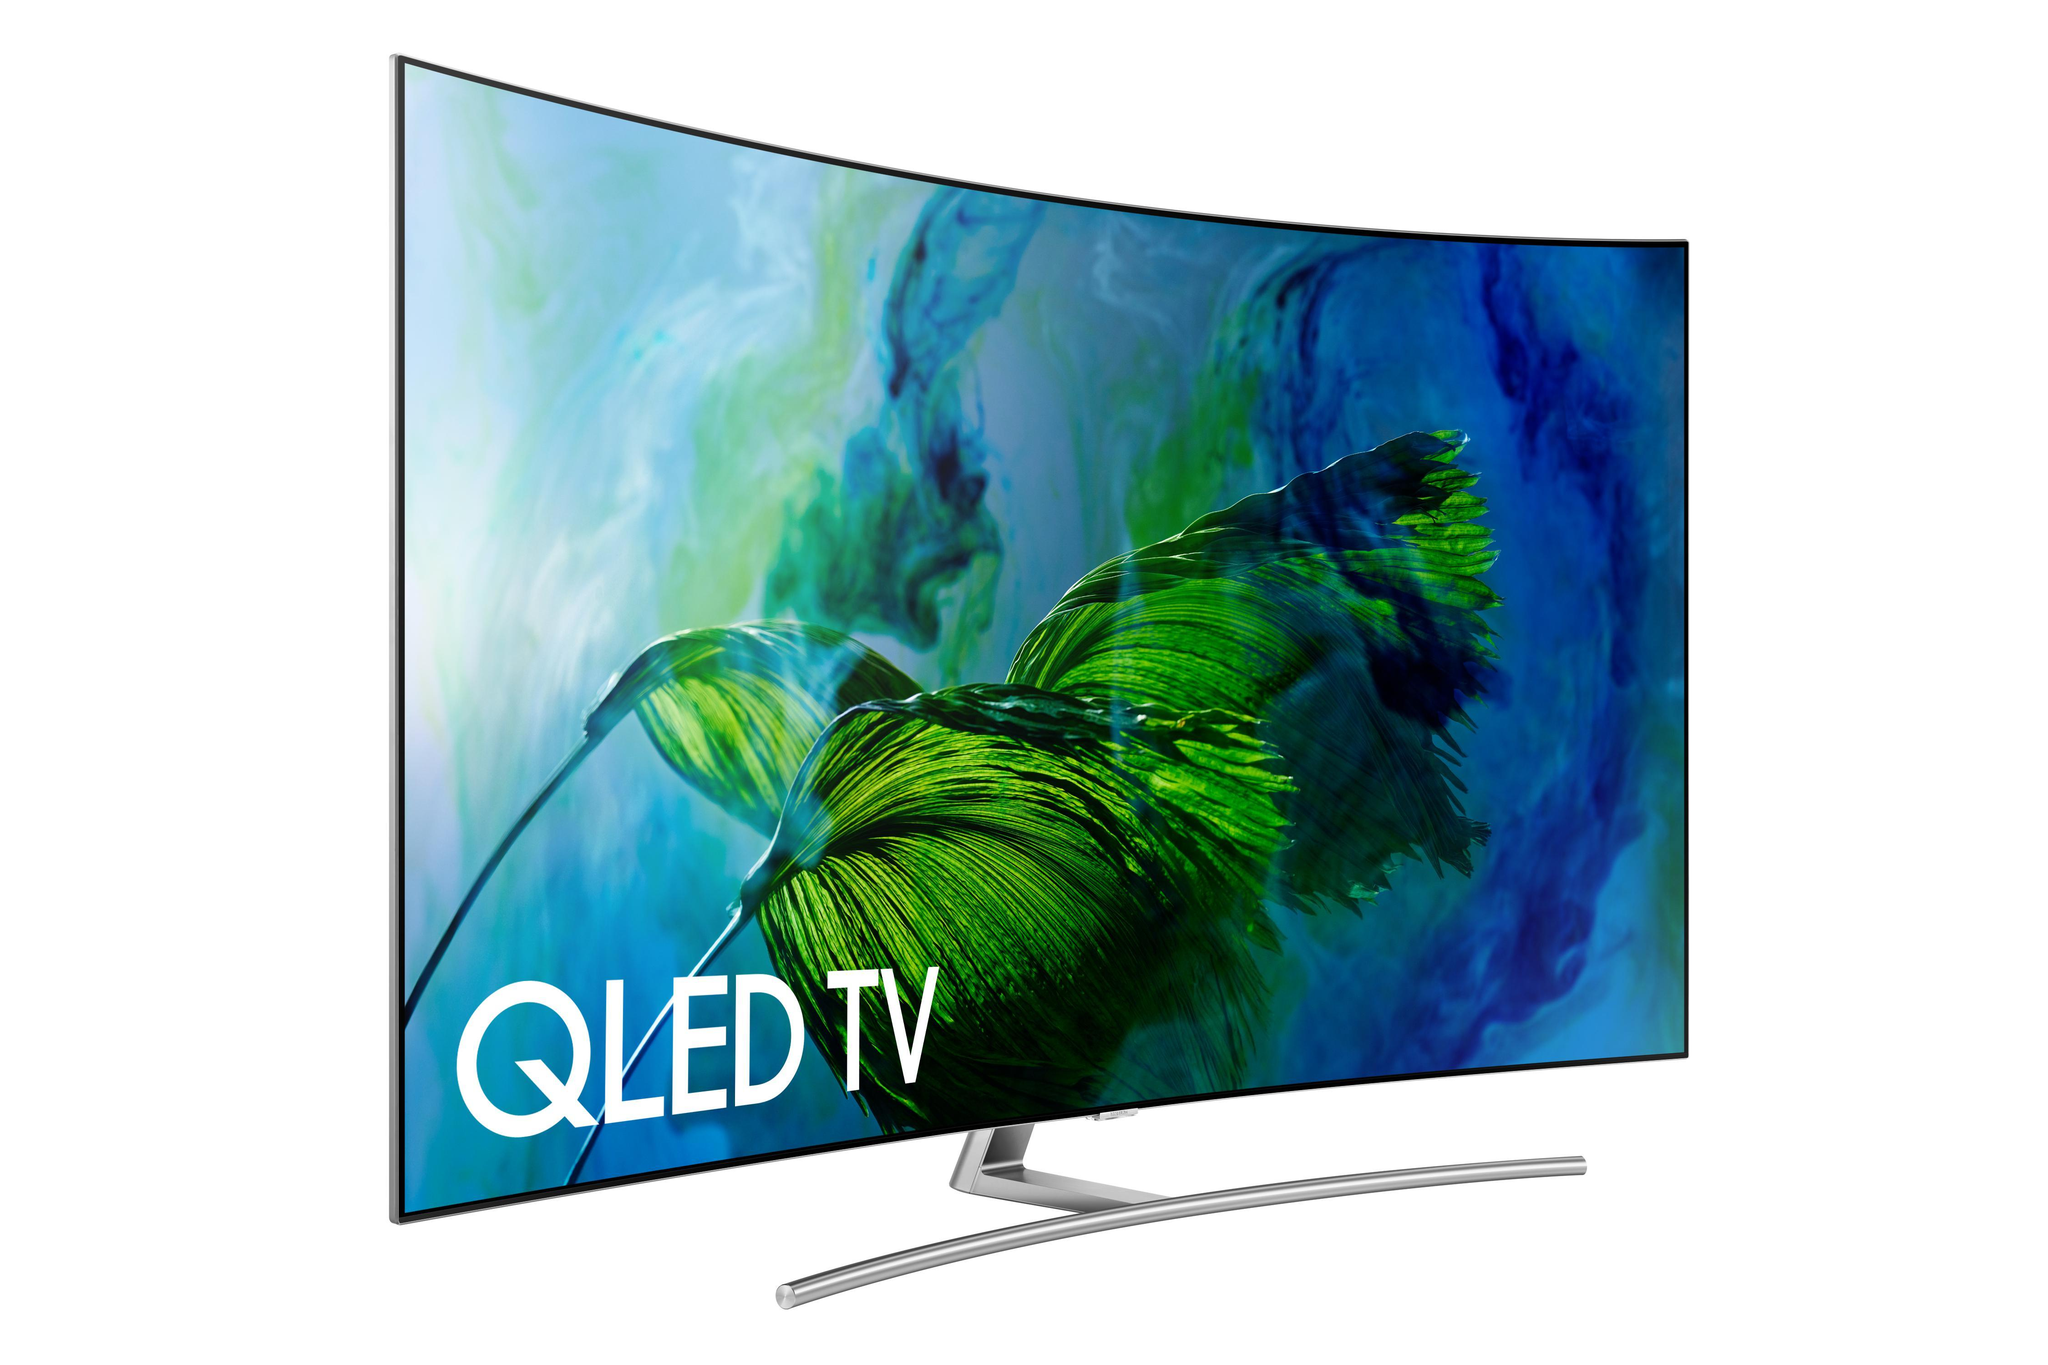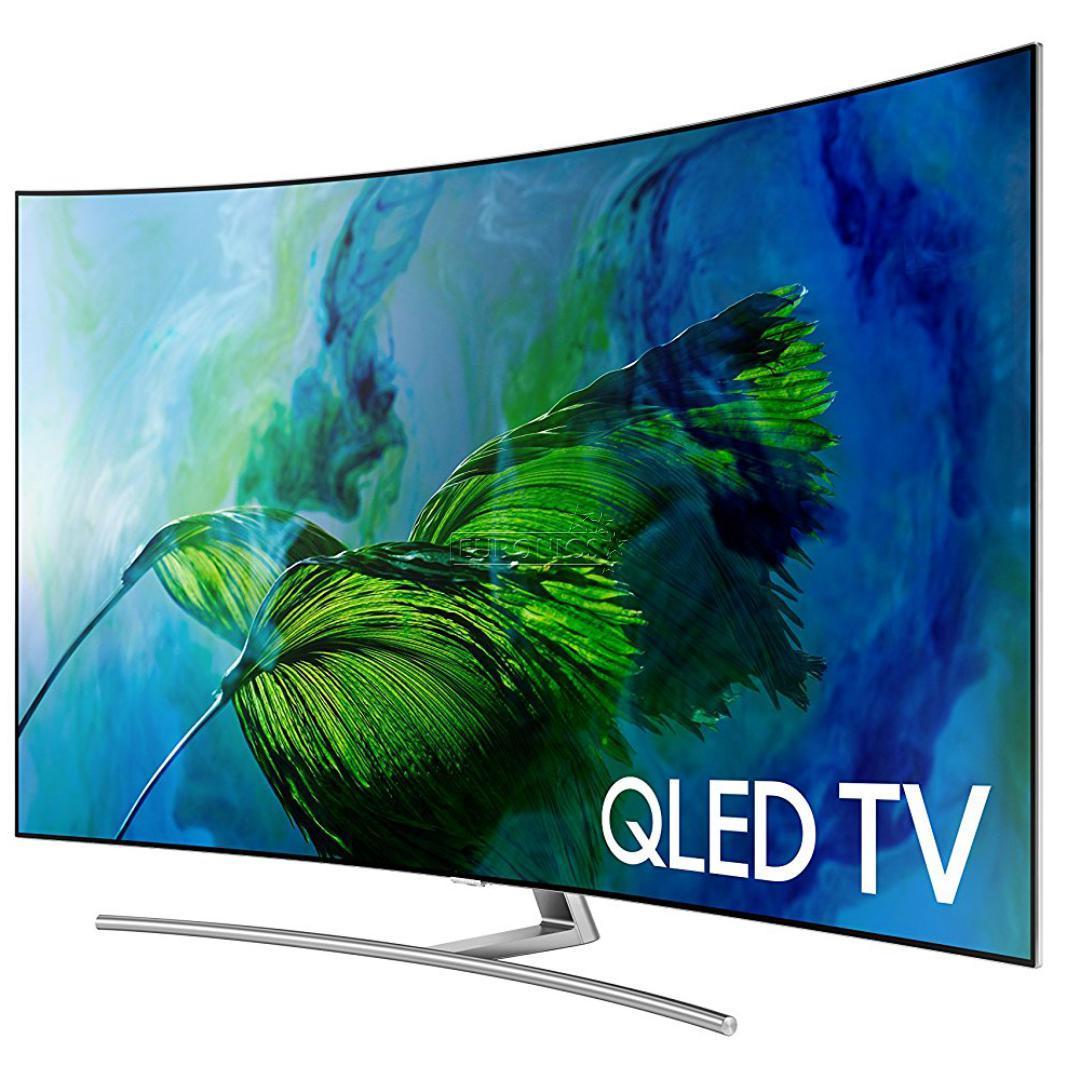The first image is the image on the left, the second image is the image on the right. Evaluate the accuracy of this statement regarding the images: "Each image contains a single screen, and left and right images feature different pictures on the screens.". Is it true? Answer yes or no. No. The first image is the image on the left, the second image is the image on the right. For the images shown, is this caption "there is a curved tv on a metal stand with wording in the corner" true? Answer yes or no. Yes. 